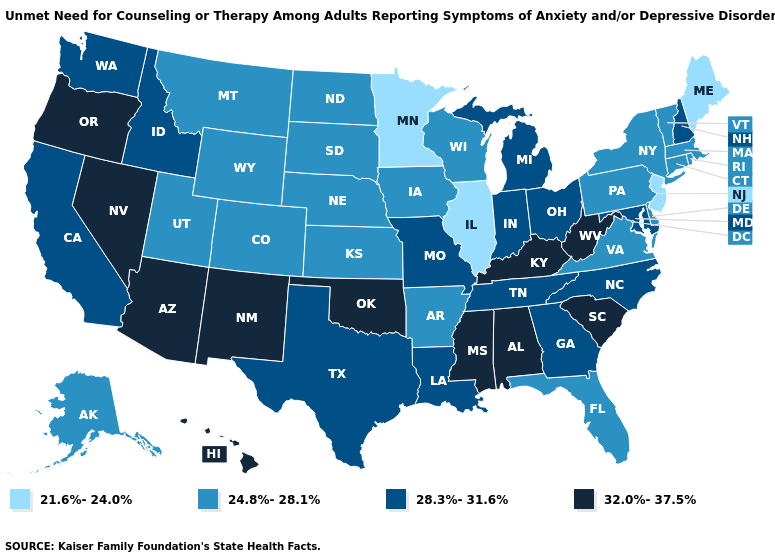What is the value of Mississippi?
Write a very short answer. 32.0%-37.5%. Among the states that border New Mexico , which have the highest value?
Answer briefly. Arizona, Oklahoma. What is the value of Minnesota?
Quick response, please. 21.6%-24.0%. Name the states that have a value in the range 21.6%-24.0%?
Keep it brief. Illinois, Maine, Minnesota, New Jersey. Which states have the lowest value in the USA?
Quick response, please. Illinois, Maine, Minnesota, New Jersey. Which states have the lowest value in the USA?
Short answer required. Illinois, Maine, Minnesota, New Jersey. What is the lowest value in the South?
Write a very short answer. 24.8%-28.1%. Which states hav the highest value in the West?
Give a very brief answer. Arizona, Hawaii, Nevada, New Mexico, Oregon. What is the highest value in the MidWest ?
Write a very short answer. 28.3%-31.6%. Name the states that have a value in the range 32.0%-37.5%?
Be succinct. Alabama, Arizona, Hawaii, Kentucky, Mississippi, Nevada, New Mexico, Oklahoma, Oregon, South Carolina, West Virginia. What is the lowest value in the USA?
Write a very short answer. 21.6%-24.0%. What is the value of Arizona?
Concise answer only. 32.0%-37.5%. Does Rhode Island have the highest value in the Northeast?
Answer briefly. No. What is the value of Tennessee?
Write a very short answer. 28.3%-31.6%. 